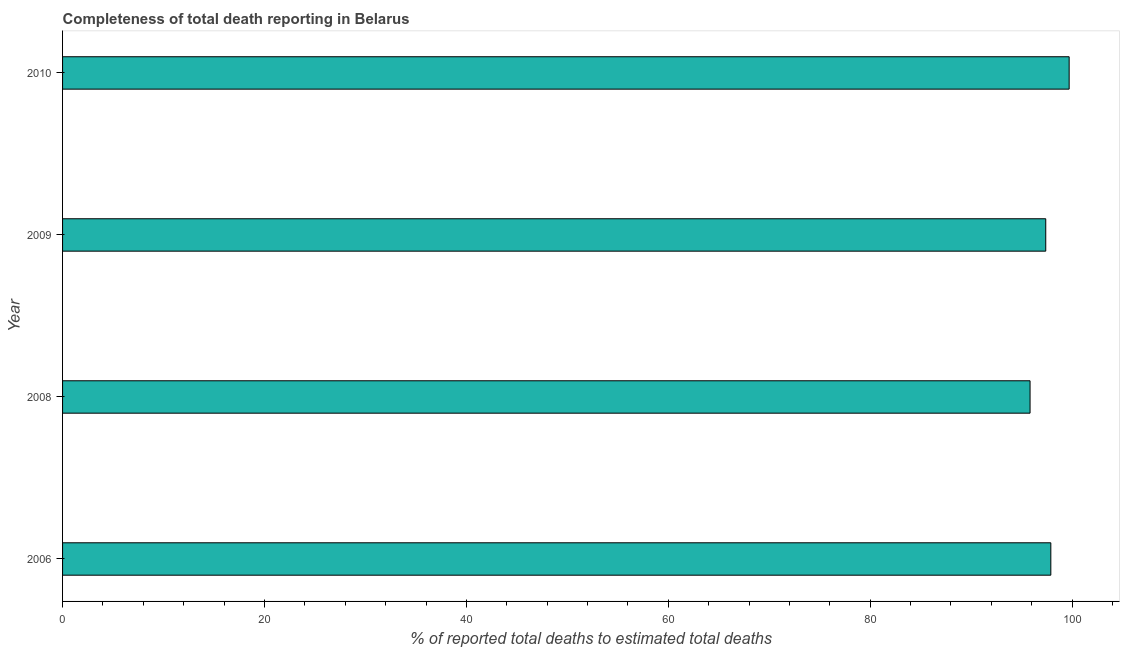Does the graph contain grids?
Keep it short and to the point. No. What is the title of the graph?
Provide a short and direct response. Completeness of total death reporting in Belarus. What is the label or title of the X-axis?
Keep it short and to the point. % of reported total deaths to estimated total deaths. What is the completeness of total death reports in 2009?
Provide a short and direct response. 97.39. Across all years, what is the maximum completeness of total death reports?
Ensure brevity in your answer.  99.71. Across all years, what is the minimum completeness of total death reports?
Your answer should be compact. 95.83. In which year was the completeness of total death reports maximum?
Ensure brevity in your answer.  2010. What is the sum of the completeness of total death reports?
Keep it short and to the point. 390.82. What is the difference between the completeness of total death reports in 2006 and 2010?
Ensure brevity in your answer.  -1.82. What is the average completeness of total death reports per year?
Offer a very short reply. 97.7. What is the median completeness of total death reports?
Your answer should be compact. 97.64. In how many years, is the completeness of total death reports greater than 60 %?
Your answer should be compact. 4. What is the ratio of the completeness of total death reports in 2008 to that in 2010?
Give a very brief answer. 0.96. What is the difference between the highest and the second highest completeness of total death reports?
Your answer should be very brief. 1.82. What is the difference between the highest and the lowest completeness of total death reports?
Make the answer very short. 3.87. How many bars are there?
Keep it short and to the point. 4. Are all the bars in the graph horizontal?
Your answer should be very brief. Yes. How many years are there in the graph?
Make the answer very short. 4. What is the difference between two consecutive major ticks on the X-axis?
Provide a succinct answer. 20. Are the values on the major ticks of X-axis written in scientific E-notation?
Your answer should be very brief. No. What is the % of reported total deaths to estimated total deaths of 2006?
Give a very brief answer. 97.89. What is the % of reported total deaths to estimated total deaths in 2008?
Provide a short and direct response. 95.83. What is the % of reported total deaths to estimated total deaths in 2009?
Offer a very short reply. 97.39. What is the % of reported total deaths to estimated total deaths of 2010?
Give a very brief answer. 99.71. What is the difference between the % of reported total deaths to estimated total deaths in 2006 and 2008?
Provide a short and direct response. 2.06. What is the difference between the % of reported total deaths to estimated total deaths in 2006 and 2009?
Provide a succinct answer. 0.5. What is the difference between the % of reported total deaths to estimated total deaths in 2006 and 2010?
Make the answer very short. -1.82. What is the difference between the % of reported total deaths to estimated total deaths in 2008 and 2009?
Provide a short and direct response. -1.56. What is the difference between the % of reported total deaths to estimated total deaths in 2008 and 2010?
Offer a very short reply. -3.87. What is the difference between the % of reported total deaths to estimated total deaths in 2009 and 2010?
Keep it short and to the point. -2.32. What is the ratio of the % of reported total deaths to estimated total deaths in 2006 to that in 2010?
Offer a very short reply. 0.98. 